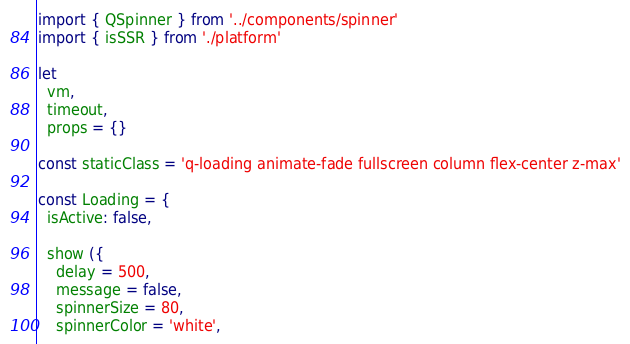<code> <loc_0><loc_0><loc_500><loc_500><_JavaScript_>import { QSpinner } from '../components/spinner'
import { isSSR } from './platform'

let
  vm,
  timeout,
  props = {}

const staticClass = 'q-loading animate-fade fullscreen column flex-center z-max'

const Loading = {
  isActive: false,

  show ({
    delay = 500,
    message = false,
    spinnerSize = 80,
    spinnerColor = 'white',</code> 